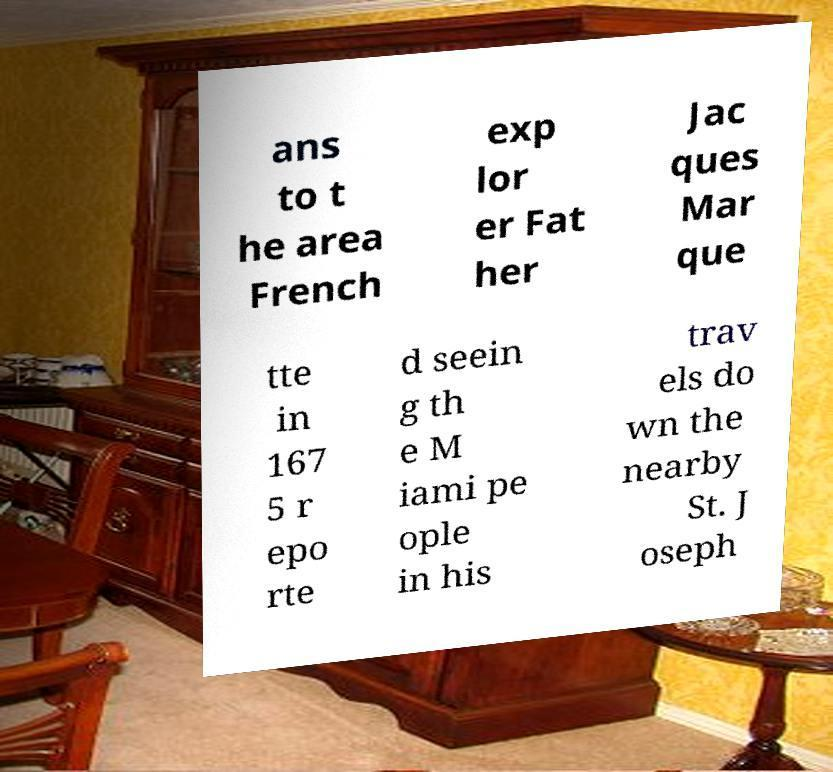I need the written content from this picture converted into text. Can you do that? ans to t he area French exp lor er Fat her Jac ques Mar que tte in 167 5 r epo rte d seein g th e M iami pe ople in his trav els do wn the nearby St. J oseph 